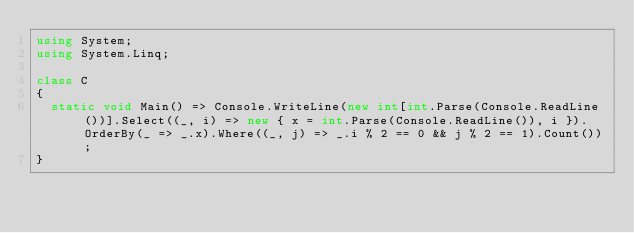<code> <loc_0><loc_0><loc_500><loc_500><_C#_>using System;
using System.Linq;

class C
{
	static void Main() => Console.WriteLine(new int[int.Parse(Console.ReadLine())].Select((_, i) => new { x = int.Parse(Console.ReadLine()), i }).OrderBy(_ => _.x).Where((_, j) => _.i % 2 == 0 && j % 2 == 1).Count());
}
</code> 